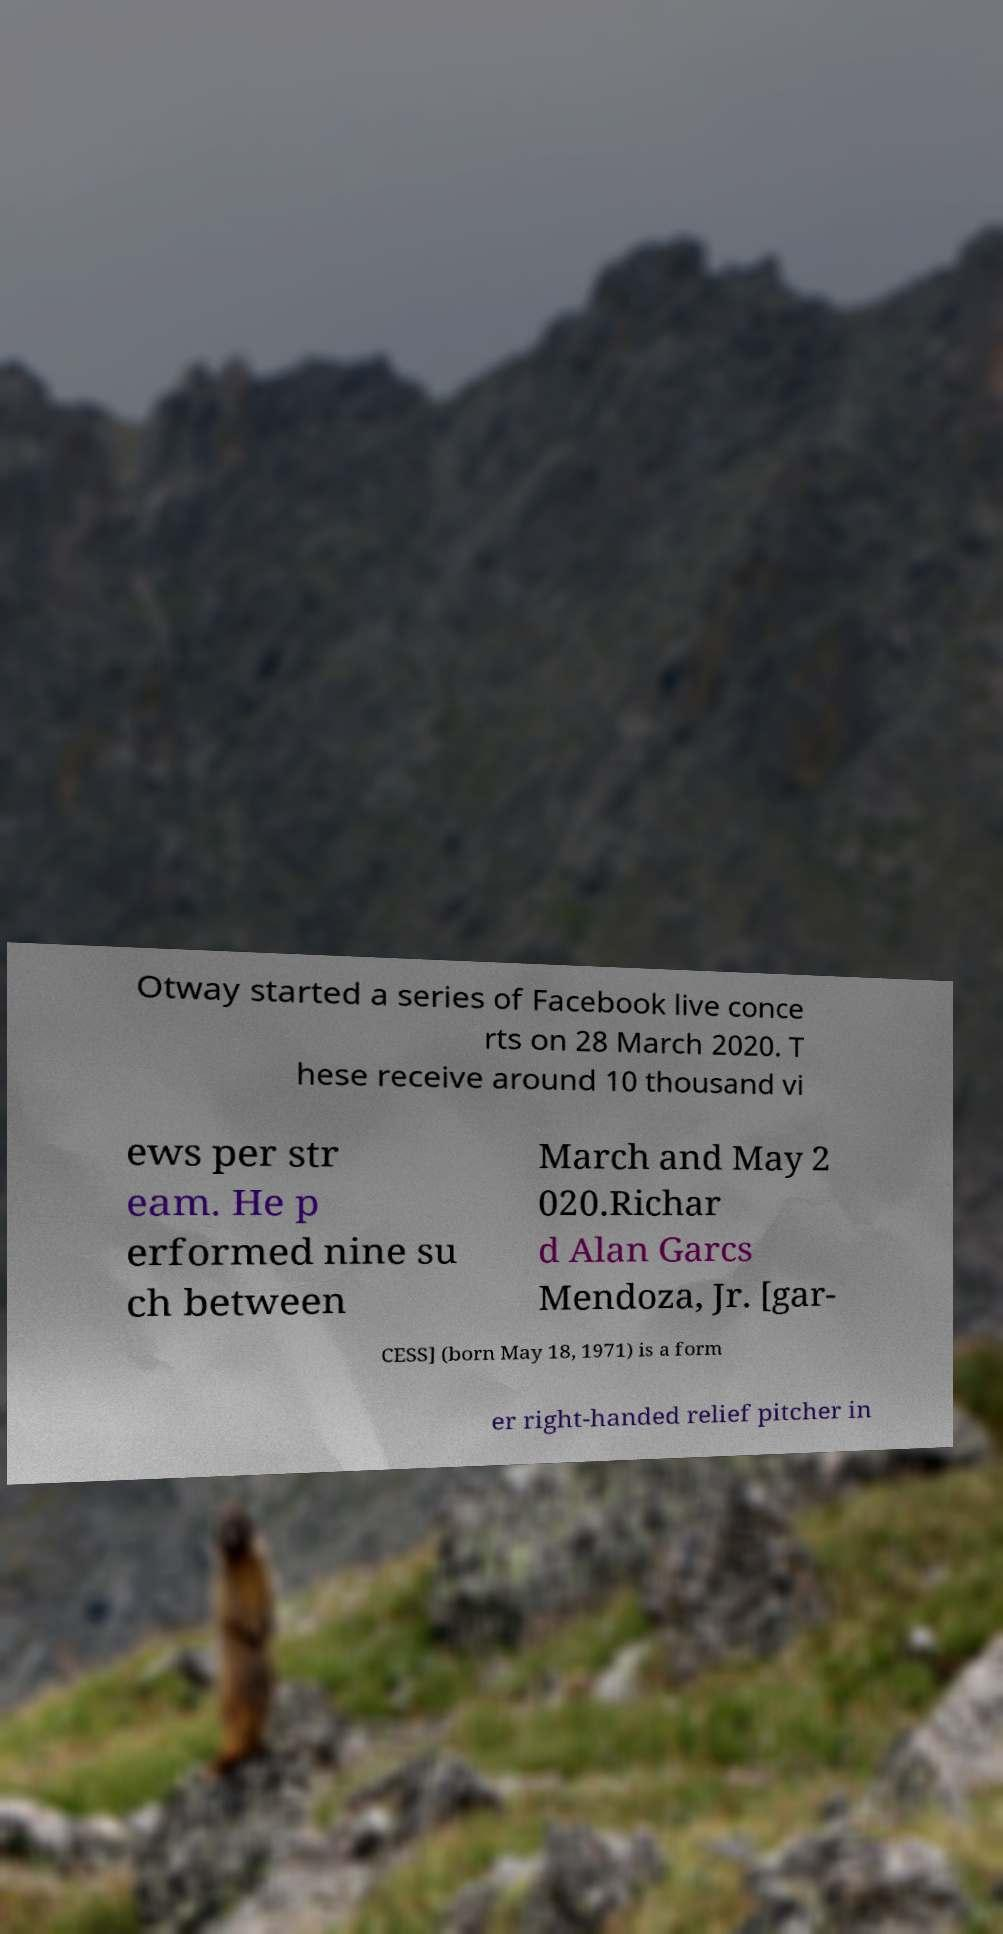Please identify and transcribe the text found in this image. Otway started a series of Facebook live conce rts on 28 March 2020. T hese receive around 10 thousand vi ews per str eam. He p erformed nine su ch between March and May 2 020.Richar d Alan Garcs Mendoza, Jr. [gar- CESS] (born May 18, 1971) is a form er right-handed relief pitcher in 